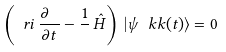<formula> <loc_0><loc_0><loc_500><loc_500>\left ( \ r i \, \frac { \partial \ \, } { \partial t } - \frac { 1 } { } \, \hat { H } \right ) \, | \psi _ { \ } k k ( t ) \rangle = 0</formula> 